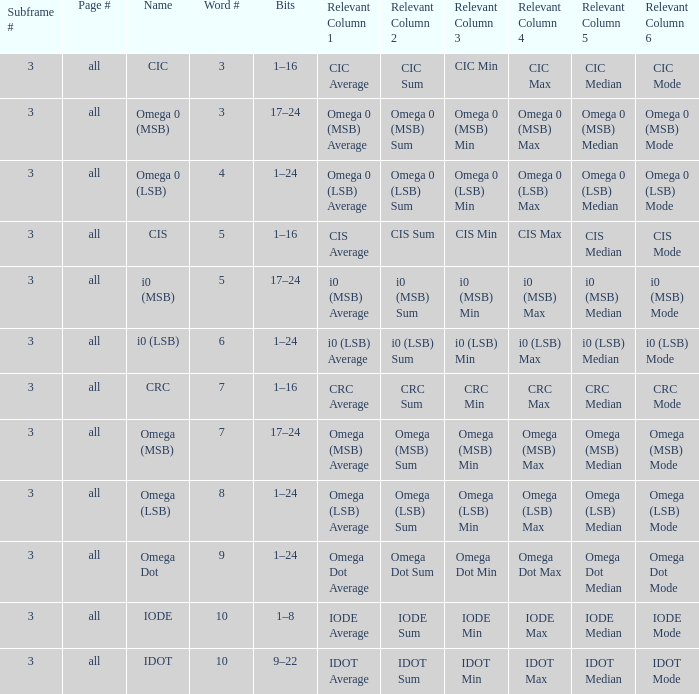What is the total word count with a subframe count greater than 3? None. Could you parse the entire table as a dict? {'header': ['Subframe #', 'Page #', 'Name', 'Word #', 'Bits', 'Relevant Column 1', 'Relevant Column 2', 'Relevant Column 3', 'Relevant Column 4', 'Relevant Column 5', 'Relevant Column 6'], 'rows': [['3', 'all', 'CIC', '3', '1–16', 'CIC Average', 'CIC Sum', 'CIC Min', 'CIC Max', 'CIC Median', 'CIC Mode'], ['3', 'all', 'Omega 0 (MSB)', '3', '17–24', 'Omega 0 (MSB) Average', 'Omega 0 (MSB) Sum', 'Omega 0 (MSB) Min', 'Omega 0 (MSB) Max', 'Omega 0 (MSB) Median', 'Omega 0 (MSB) Mode'], ['3', 'all', 'Omega 0 (LSB)', '4', '1–24', 'Omega 0 (LSB) Average', 'Omega 0 (LSB) Sum', 'Omega 0 (LSB) Min', 'Omega 0 (LSB) Max', 'Omega 0 (LSB) Median', 'Omega 0 (LSB) Mode'], ['3', 'all', 'CIS', '5', '1–16', 'CIS Average', 'CIS Sum', 'CIS Min', 'CIS Max', 'CIS Median', 'CIS Mode'], ['3', 'all', 'i0 (MSB)', '5', '17–24', 'i0 (MSB) Average', 'i0 (MSB) Sum', 'i0 (MSB) Min', 'i0 (MSB) Max', 'i0 (MSB) Median', 'i0 (MSB) Mode'], ['3', 'all', 'i0 (LSB)', '6', '1–24', 'i0 (LSB) Average', 'i0 (LSB) Sum', 'i0 (LSB) Min', 'i0 (LSB) Max', 'i0 (LSB) Median', 'i0 (LSB) Mode'], ['3', 'all', 'CRC', '7', '1–16', 'CRC Average', 'CRC Sum', 'CRC Min', 'CRC Max', 'CRC Median', 'CRC Mode'], ['3', 'all', 'Omega (MSB)', '7', '17–24', 'Omega (MSB) Average', 'Omega (MSB) Sum', 'Omega (MSB) Min', 'Omega (MSB) Max', 'Omega (MSB) Median', 'Omega (MSB) Mode'], ['3', 'all', 'Omega (LSB)', '8', '1–24', 'Omega (LSB) Average', 'Omega (LSB) Sum', 'Omega (LSB) Min', 'Omega (LSB) Max', 'Omega (LSB) Median', 'Omega (LSB) Mode'], ['3', 'all', 'Omega Dot', '9', '1–24', 'Omega Dot Average', 'Omega Dot Sum', 'Omega Dot Min', 'Omega Dot Max', 'Omega Dot Median', 'Omega Dot Mode'], ['3', 'all', 'IODE', '10', '1–8', 'IODE Average', 'IODE Sum', 'IODE Min', 'IODE Max', 'IODE Median', 'IODE Mode'], ['3', 'all', 'IDOT', '10', '9–22', 'IDOT Average', 'IDOT Sum', 'IDOT Min', 'IDOT Max', 'IDOT Median', 'IDOT Mode']]} 